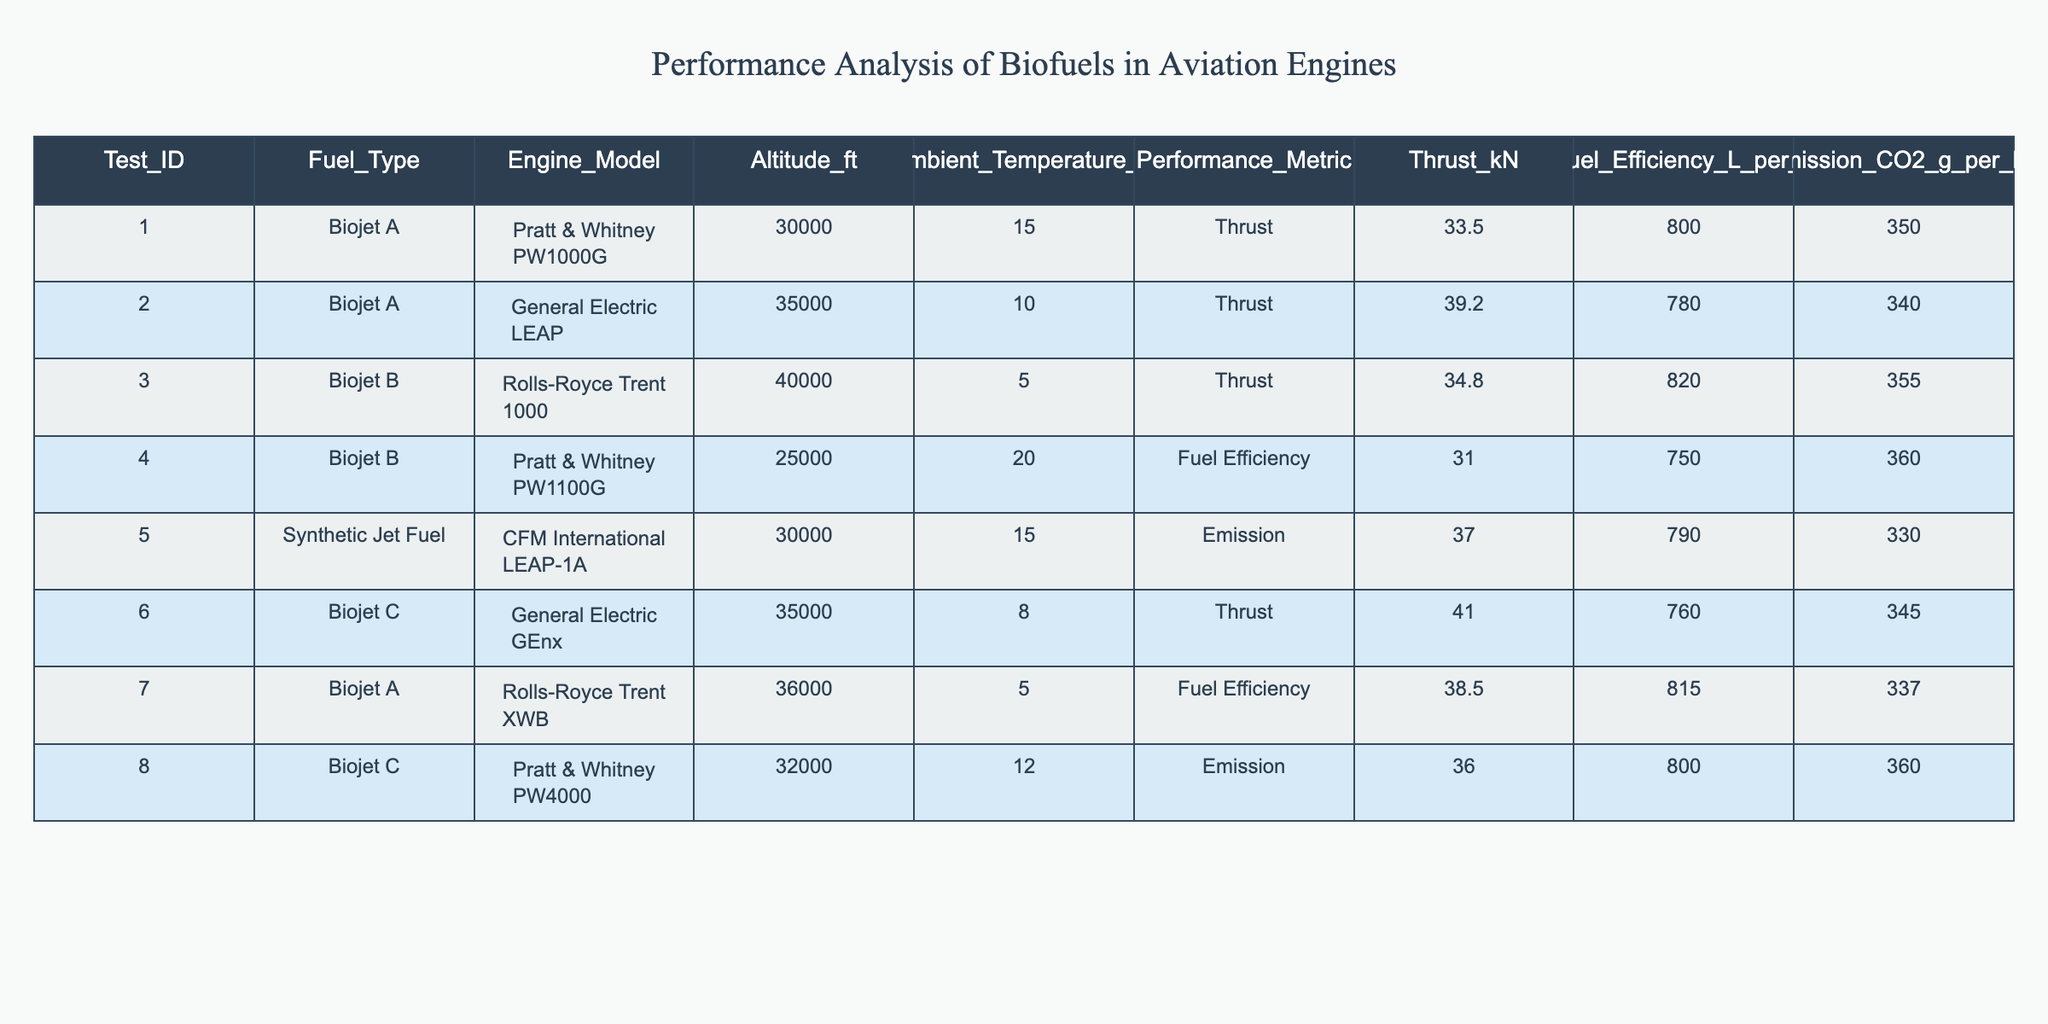What is the thrust produced by the General Electric LEAP engine using Biojet A? According to the table, the thrust produced by the General Electric LEAP engine with Biojet A is 39.2 kN, as indicated in the row with Test_ID 2.
Answer: 39.2 kN What is the fuel efficiency of the Rolls-Royce Trent XWB engine using Biojet A? The table shows that the Rolls-Royce Trent XWB engine using Biojet A does not have a fuel efficiency metric listed; instead, it provides thrust, which is 38.5 kN.
Answer: Not available What is the highest thrust value recorded among all fuels in the table? The thrust values can be extracted from all rows. The highest value is 41.0 kN from the General Electric GEnx engine using Biojet C (Test_ID 6).
Answer: 41.0 kN Is the emission of CO2 during the use of Synthetic Jet Fuel lower than that of Biojet C? The CO2 emissions for Synthetic Jet Fuel is 330 g per kN, while for Biojet C (Test_ID 8), it is 360 g per kN. Therefore, the emission from Synthetic Jet Fuel is indeed lower.
Answer: Yes What is the average fuel efficiency of Biojet A across the tested engines? The fuel efficiency values for Biojet A are 800 L/h (Test_ID 1) and 780 L/h (Test_ID 2). To find the average: (800 + 780) / 2 = 790 L/h.
Answer: 790 L/h Which engine model has the least fuel efficiency when using any biofuel in the table? The table lists the fuel efficiency values as 750 L/h for the Pratt & Whitney PW1100G using Biojet B (Test_ID 4). By comparing all fuel efficiency data, this is the lowest recorded.
Answer: 750 L/h Which biofuel has the highest CO2 emissions when considering all test data? By reviewing the CO2 emissions values in the table, the highest emission is with Biojet B (Test_ID 3) at 355 g per kN.
Answer: 355 g per kN What is the thrust difference between Biojet A using the Pratt & Whitney PW1000G and Biojet B using the Rolls-Royce Trent 1000? The thrust for Biojet A using PW1000G is 33.5 kN (Test_ID 1) and for Biojet B using Trent 1000 is 34.8 kN (Test_ID 3). The difference is 34.8 - 33.5 = 1.3 kN.
Answer: 1.3 kN Is the ambient temperature lower during flights at 40,000 feet compared to 30,000 feet regardless of the fuel type? The ambient temperatures at 40,000 feet are recorded as 5°C (Test_ID 3) and at 30,000 feet is 15°C (Test_ID 1 and Test_ID 5). The temperature at 40,000 feet is indeed lower.
Answer: Yes 